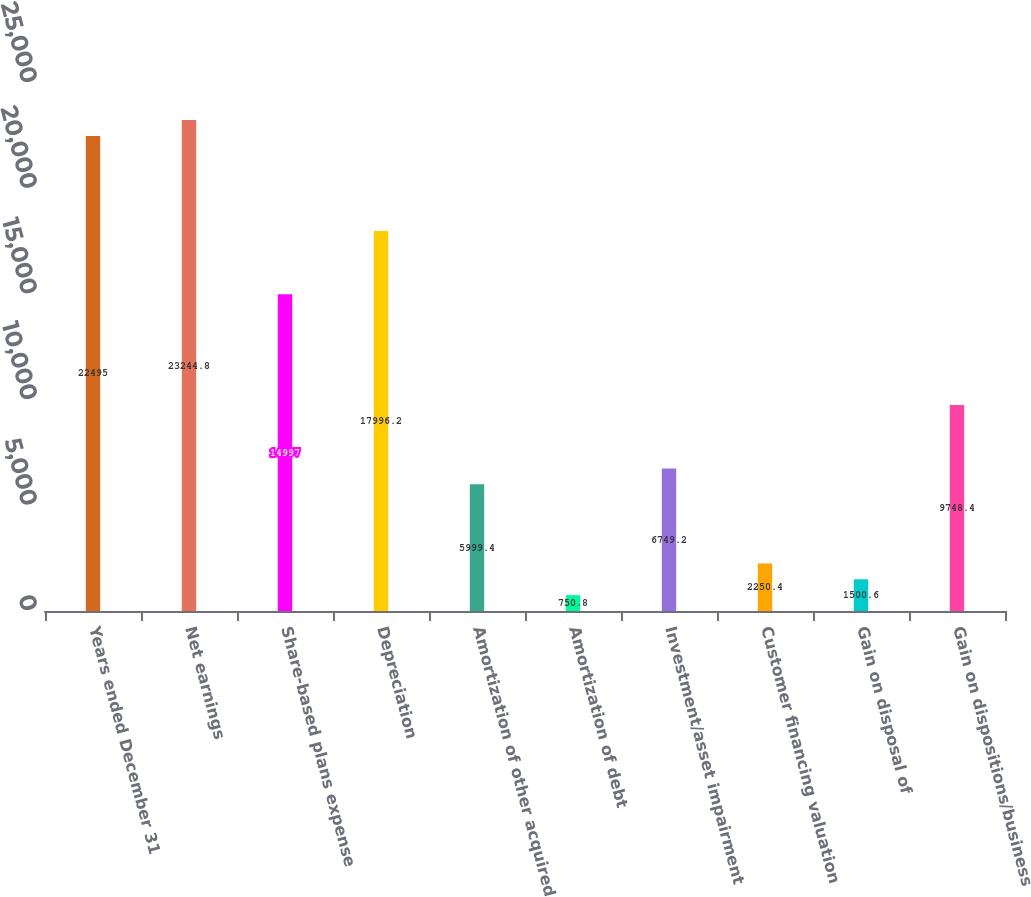Convert chart. <chart><loc_0><loc_0><loc_500><loc_500><bar_chart><fcel>Years ended December 31<fcel>Net earnings<fcel>Share-based plans expense<fcel>Depreciation<fcel>Amortization of other acquired<fcel>Amortization of debt<fcel>Investment/asset impairment<fcel>Customer financing valuation<fcel>Gain on disposal of<fcel>Gain on dispositions/business<nl><fcel>22495<fcel>23244.8<fcel>14997<fcel>17996.2<fcel>5999.4<fcel>750.8<fcel>6749.2<fcel>2250.4<fcel>1500.6<fcel>9748.4<nl></chart> 